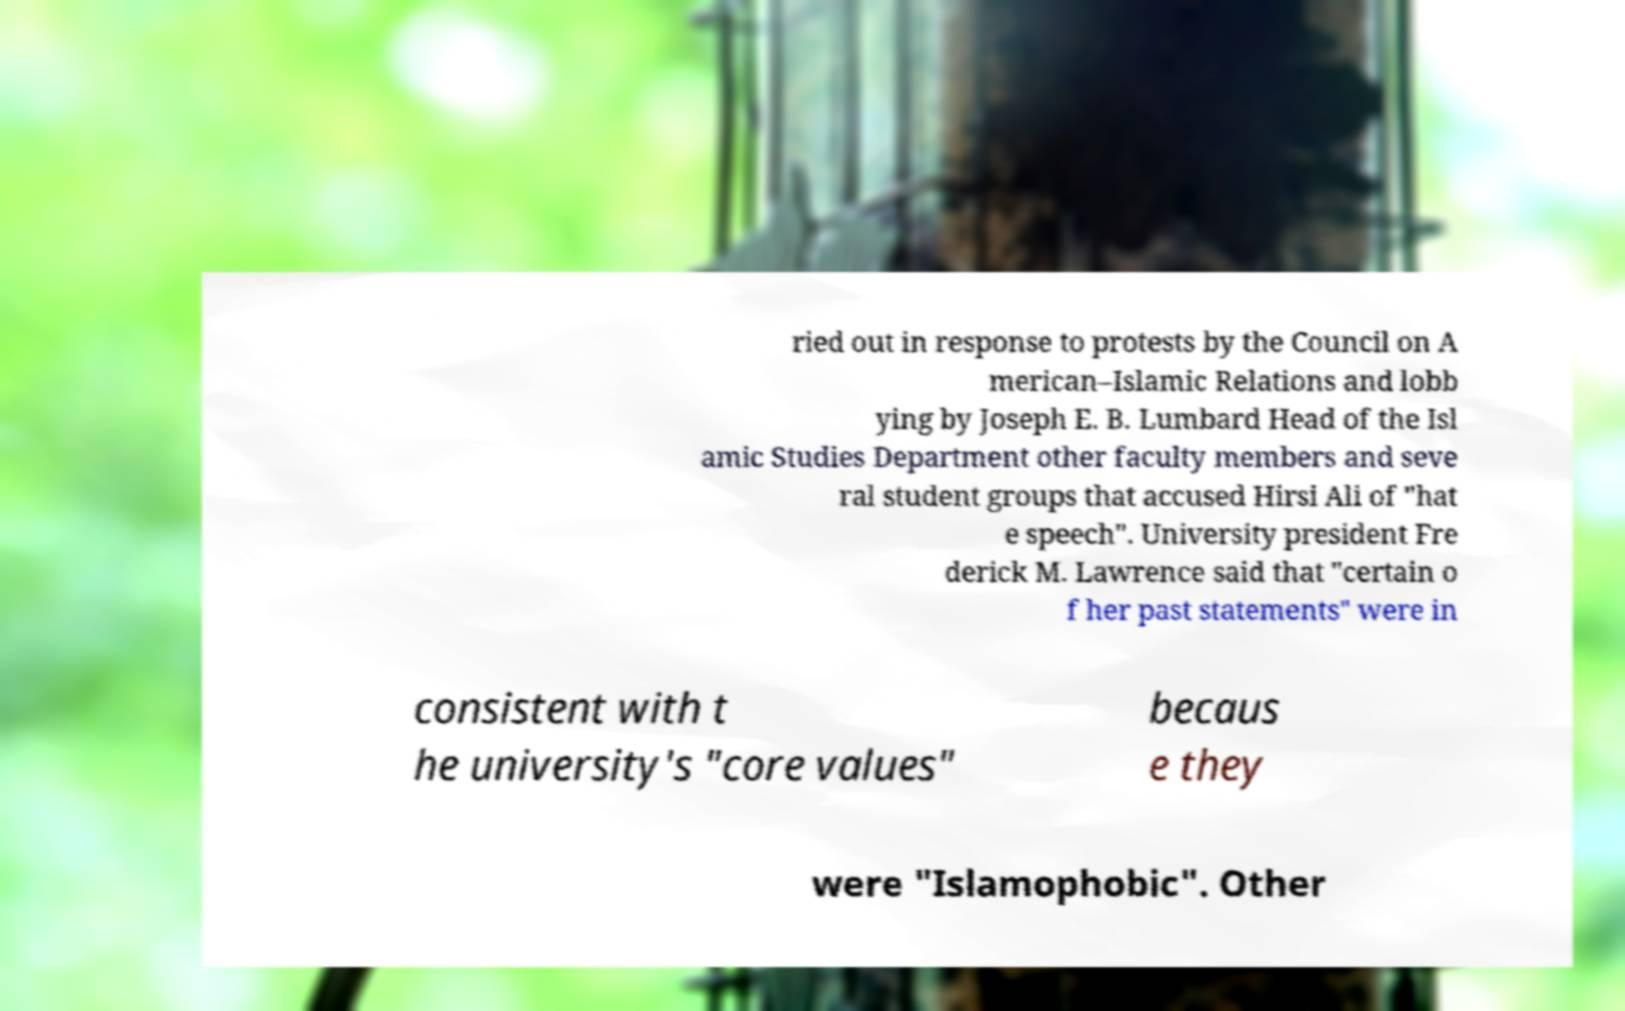Please identify and transcribe the text found in this image. ried out in response to protests by the Council on A merican–Islamic Relations and lobb ying by Joseph E. B. Lumbard Head of the Isl amic Studies Department other faculty members and seve ral student groups that accused Hirsi Ali of "hat e speech". University president Fre derick M. Lawrence said that "certain o f her past statements" were in consistent with t he university's "core values" becaus e they were "Islamophobic". Other 